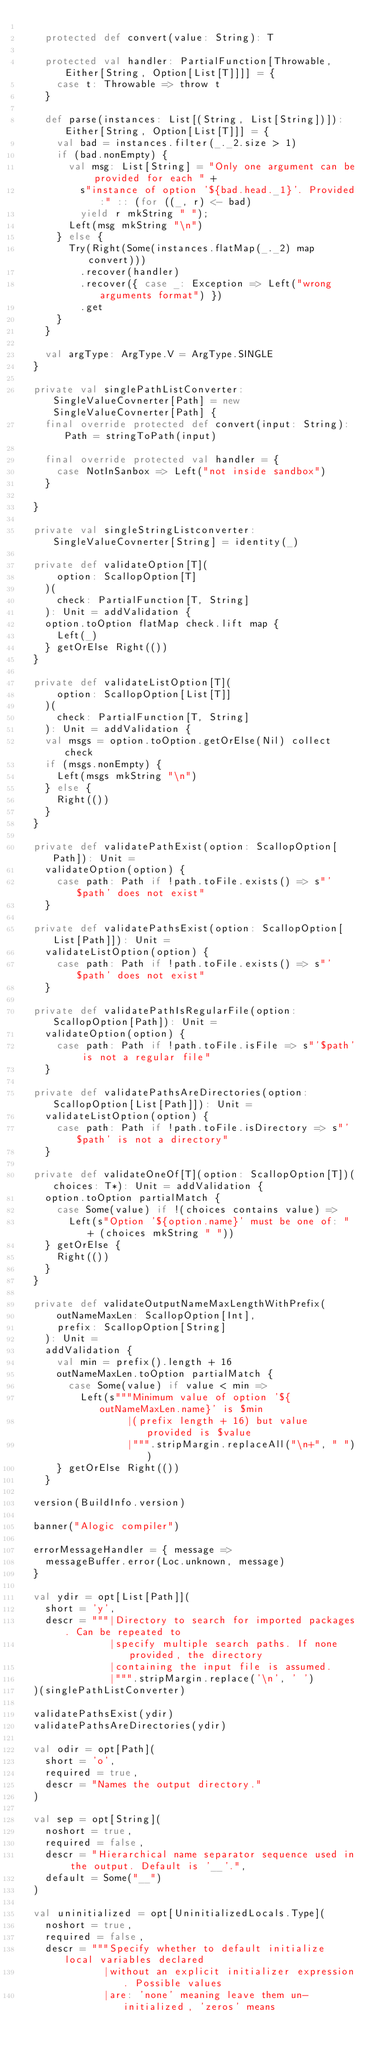<code> <loc_0><loc_0><loc_500><loc_500><_Scala_>
    protected def convert(value: String): T

    protected val handler: PartialFunction[Throwable, Either[String, Option[List[T]]]] = {
      case t: Throwable => throw t
    }

    def parse(instances: List[(String, List[String])]): Either[String, Option[List[T]]] = {
      val bad = instances.filter(_._2.size > 1)
      if (bad.nonEmpty) {
        val msg: List[String] = "Only one argument can be provided for each " +
          s"instance of option '${bad.head._1}'. Provided:" :: (for ((_, r) <- bad)
          yield r mkString " ");
        Left(msg mkString "\n")
      } else {
        Try(Right(Some(instances.flatMap(_._2) map convert)))
          .recover(handler)
          .recover({ case _: Exception => Left("wrong arguments format") })
          .get
      }
    }

    val argType: ArgType.V = ArgType.SINGLE
  }

  private val singlePathListConverter: SingleValueCovnerter[Path] = new SingleValueCovnerter[Path] {
    final override protected def convert(input: String): Path = stringToPath(input)

    final override protected val handler = {
      case NotInSanbox => Left("not inside sandbox")
    }

  }

  private val singleStringListconverter: SingleValueCovnerter[String] = identity(_)

  private def validateOption[T](
      option: ScallopOption[T]
    )(
      check: PartialFunction[T, String]
    ): Unit = addValidation {
    option.toOption flatMap check.lift map {
      Left(_)
    } getOrElse Right(())
  }

  private def validateListOption[T](
      option: ScallopOption[List[T]]
    )(
      check: PartialFunction[T, String]
    ): Unit = addValidation {
    val msgs = option.toOption.getOrElse(Nil) collect check
    if (msgs.nonEmpty) {
      Left(msgs mkString "\n")
    } else {
      Right(())
    }
  }

  private def validatePathExist(option: ScallopOption[Path]): Unit =
    validateOption(option) {
      case path: Path if !path.toFile.exists() => s"'$path' does not exist"
    }

  private def validatePathsExist(option: ScallopOption[List[Path]]): Unit =
    validateListOption(option) {
      case path: Path if !path.toFile.exists() => s"'$path' does not exist"
    }

  private def validatePathIsRegularFile(option: ScallopOption[Path]): Unit =
    validateOption(option) {
      case path: Path if !path.toFile.isFile => s"'$path' is not a regular file"
    }

  private def validatePathsAreDirectories(option: ScallopOption[List[Path]]): Unit =
    validateListOption(option) {
      case path: Path if !path.toFile.isDirectory => s"'$path' is not a directory"
    }

  private def validateOneOf[T](option: ScallopOption[T])(choices: T*): Unit = addValidation {
    option.toOption partialMatch {
      case Some(value) if !(choices contains value) =>
        Left(s"Option '${option.name}' must be one of: " + (choices mkString " "))
    } getOrElse {
      Right(())
    }
  }

  private def validateOutputNameMaxLengthWithPrefix(
      outNameMaxLen: ScallopOption[Int],
      prefix: ScallopOption[String]
    ): Unit =
    addValidation {
      val min = prefix().length + 16
      outNameMaxLen.toOption partialMatch {
        case Some(value) if value < min =>
          Left(s"""Minimum value of option '${outNameMaxLen.name}' is $min
                  |(prefix length + 16) but value provided is $value
                  |""".stripMargin.replaceAll("\n+", " "))
      } getOrElse Right(())
    }

  version(BuildInfo.version)

  banner("Alogic compiler")

  errorMessageHandler = { message =>
    messageBuffer.error(Loc.unknown, message)
  }

  val ydir = opt[List[Path]](
    short = 'y',
    descr = """|Directory to search for imported packages. Can be repeated to
               |specify multiple search paths. If none provided, the directory
               |containing the input file is assumed.
               |""".stripMargin.replace('\n', ' ')
  )(singlePathListConverter)

  validatePathsExist(ydir)
  validatePathsAreDirectories(ydir)

  val odir = opt[Path](
    short = 'o',
    required = true,
    descr = "Names the output directory."
  )

  val sep = opt[String](
    noshort = true,
    required = false,
    descr = "Hierarchical name separator sequence used in the output. Default is '__'.",
    default = Some("__")
  )

  val uninitialized = opt[UninitializedLocals.Type](
    noshort = true,
    required = false,
    descr = """Specify whether to default initialize local variables declared
              |without an explicit initializer expression. Possible values
              |are: 'none' meaning leave them un-initialized, 'zeros' means</code> 